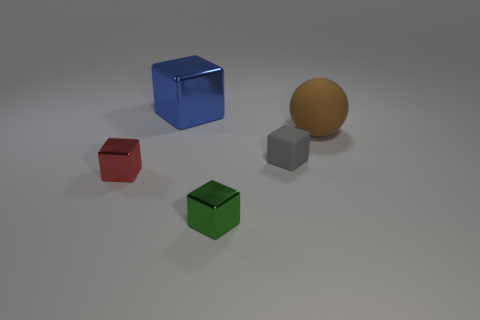Is the number of cubes behind the large shiny object the same as the number of tiny metal balls?
Keep it short and to the point. Yes. How many objects are either large brown spheres or purple metal cylinders?
Provide a short and direct response. 1. Is there any other thing that is the same shape as the big metallic object?
Offer a very short reply. Yes. There is a tiny metallic thing that is left of the small green metal cube that is left of the gray matte thing; what shape is it?
Provide a short and direct response. Cube. There is a thing that is made of the same material as the brown ball; what shape is it?
Keep it short and to the point. Cube. What size is the shiny object that is behind the rubber thing that is behind the tiny gray rubber cube?
Your answer should be very brief. Large. The big blue object has what shape?
Keep it short and to the point. Cube. What number of small objects are blue shiny blocks or green matte balls?
Give a very brief answer. 0. What is the size of the blue shiny object that is the same shape as the tiny matte thing?
Your answer should be compact. Large. How many large things are behind the big brown rubber sphere and in front of the blue object?
Offer a terse response. 0. 